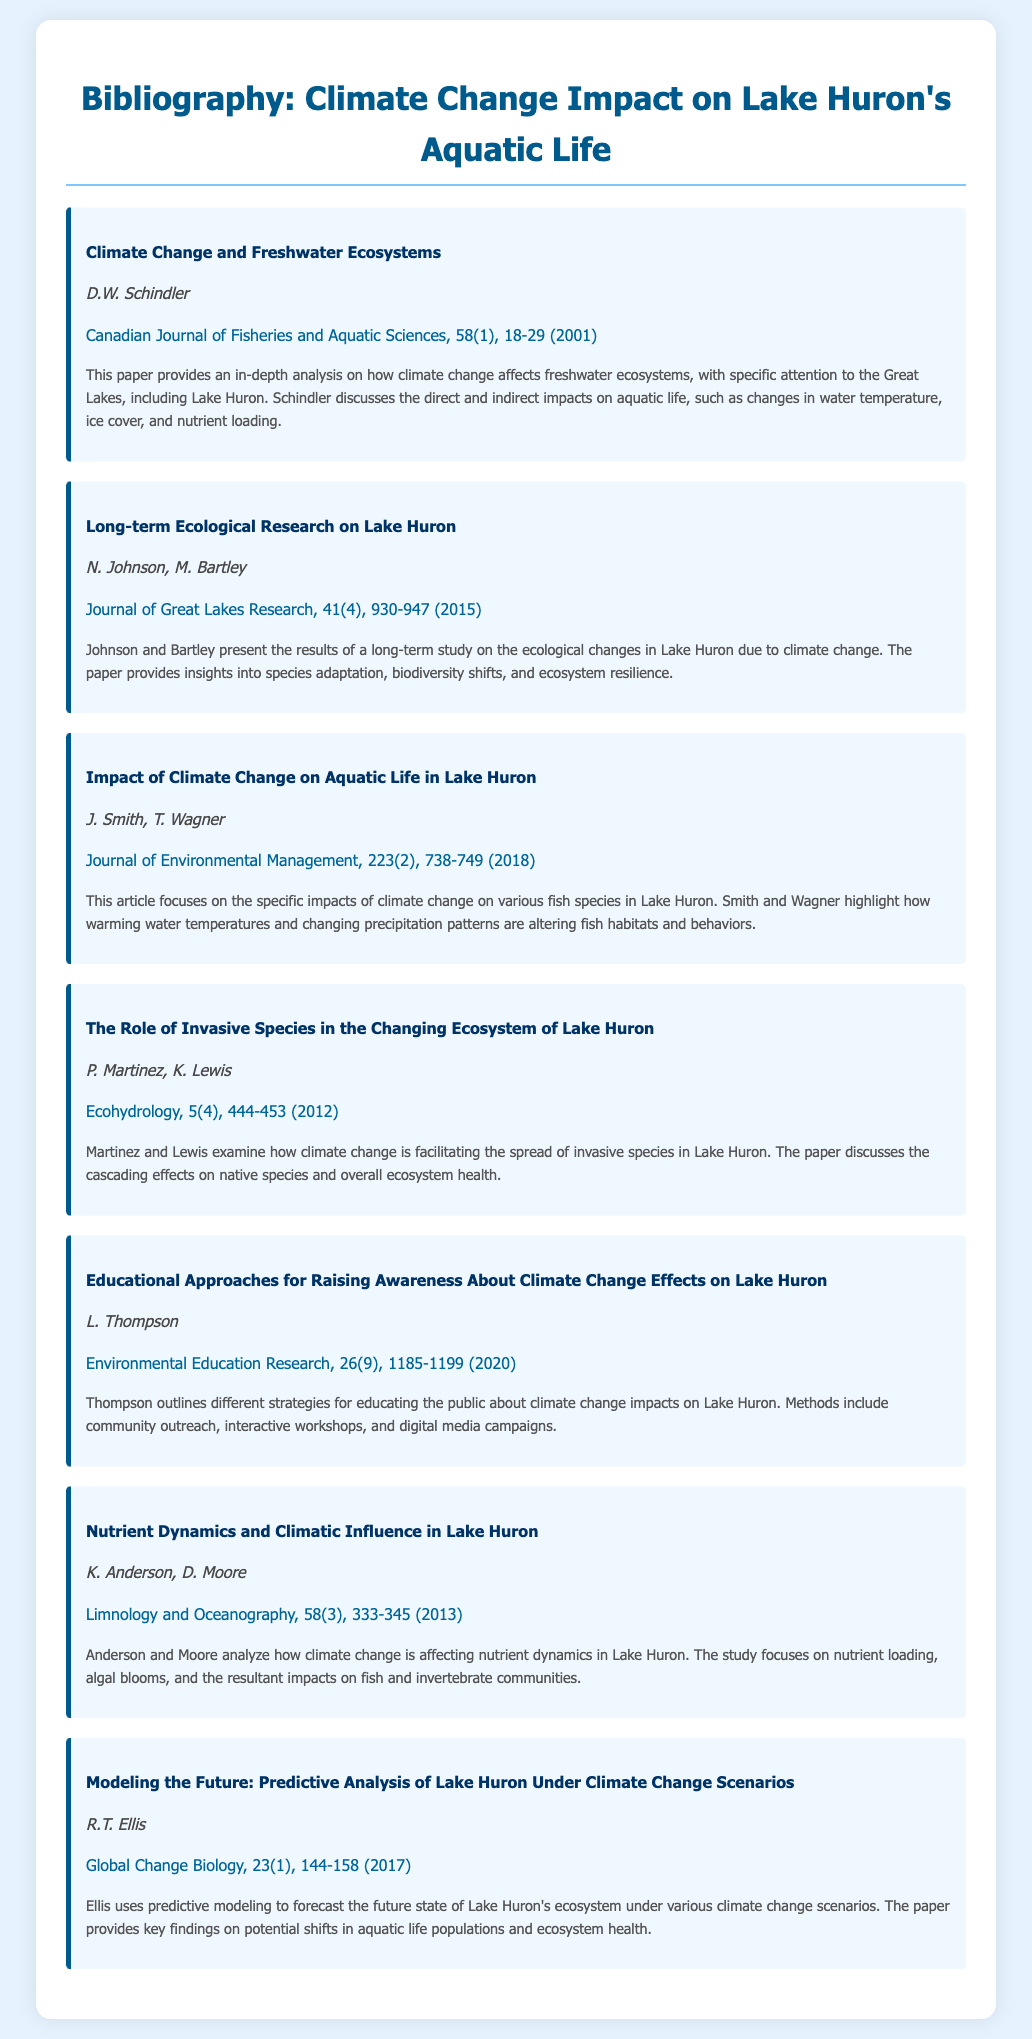what is the title of the first paper listed? The title of the first paper is provided in the bibliography section under the corresponding item.
Answer: Climate Change and Freshwater Ecosystems who are the authors of the paper on invasive species? The authors' names are listed with the paper details in the document.
Answer: P. Martinez, K. Lewis in what year was the article about educating the public published? The publication year can be found at the end of the citation for that article.
Answer: 2020 which journal published the study on nutrient dynamics? The journal name is included with each bibliography item, indicating where the study was published.
Answer: Limnology and Oceanography what are the main topics discussed in the paper by Smith and Wagner? The summary provided outlines the specific themes or findings of the paper.
Answer: Impacts of climate change on various fish species how did climate change affect the ecological changes in Lake Huron according to Johnson and Bartley? Insights into their findings can be gleaned from the summary included in the bibliography.
Answer: Species adaptation, biodiversity shifts, and ecosystem resilience what is the volume number of the article on long-term ecological research? The volume number is specified in the citation for that article in the document.
Answer: 41 who researched nutrient loading and algal blooms in Lake Huron? Researcher names are listed with the respective papers in the bibliography section.
Answer: K. Anderson, D. Moore what is the focus of the study by R.T. Ellis? The summary provides a brief overview of what the research article addresses.
Answer: Predictive modeling for future ecosystem states 